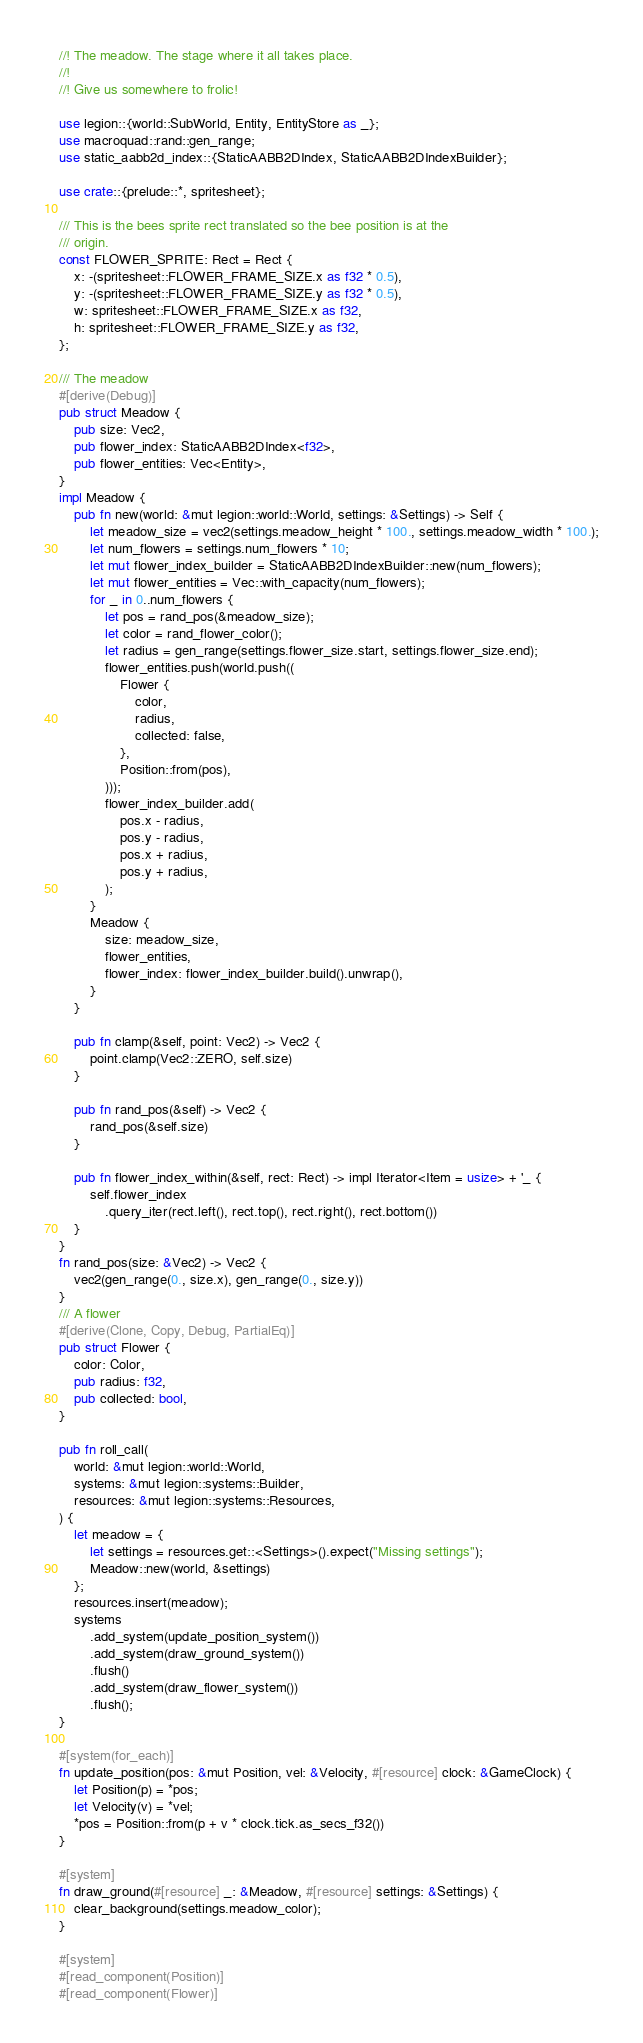<code> <loc_0><loc_0><loc_500><loc_500><_Rust_>//! The meadow. The stage where it all takes place.
//!
//! Give us somewhere to frolic!

use legion::{world::SubWorld, Entity, EntityStore as _};
use macroquad::rand::gen_range;
use static_aabb2d_index::{StaticAABB2DIndex, StaticAABB2DIndexBuilder};

use crate::{prelude::*, spritesheet};

/// This is the bees sprite rect translated so the bee position is at the
/// origin.
const FLOWER_SPRITE: Rect = Rect {
    x: -(spritesheet::FLOWER_FRAME_SIZE.x as f32 * 0.5),
    y: -(spritesheet::FLOWER_FRAME_SIZE.y as f32 * 0.5),
    w: spritesheet::FLOWER_FRAME_SIZE.x as f32,
    h: spritesheet::FLOWER_FRAME_SIZE.y as f32,
};

/// The meadow
#[derive(Debug)]
pub struct Meadow {
    pub size: Vec2,
    pub flower_index: StaticAABB2DIndex<f32>,
    pub flower_entities: Vec<Entity>,
}
impl Meadow {
    pub fn new(world: &mut legion::world::World, settings: &Settings) -> Self {
        let meadow_size = vec2(settings.meadow_height * 100., settings.meadow_width * 100.);
        let num_flowers = settings.num_flowers * 10;
        let mut flower_index_builder = StaticAABB2DIndexBuilder::new(num_flowers);
        let mut flower_entities = Vec::with_capacity(num_flowers);
        for _ in 0..num_flowers {
            let pos = rand_pos(&meadow_size);
            let color = rand_flower_color();
            let radius = gen_range(settings.flower_size.start, settings.flower_size.end);
            flower_entities.push(world.push((
                Flower {
                    color,
                    radius,
                    collected: false,
                },
                Position::from(pos),
            )));
            flower_index_builder.add(
                pos.x - radius,
                pos.y - radius,
                pos.x + radius,
                pos.y + radius,
            );
        }
        Meadow {
            size: meadow_size,
            flower_entities,
            flower_index: flower_index_builder.build().unwrap(),
        }
    }

    pub fn clamp(&self, point: Vec2) -> Vec2 {
        point.clamp(Vec2::ZERO, self.size)
    }

    pub fn rand_pos(&self) -> Vec2 {
        rand_pos(&self.size)
    }

    pub fn flower_index_within(&self, rect: Rect) -> impl Iterator<Item = usize> + '_ {
        self.flower_index
            .query_iter(rect.left(), rect.top(), rect.right(), rect.bottom())
    }
}
fn rand_pos(size: &Vec2) -> Vec2 {
    vec2(gen_range(0., size.x), gen_range(0., size.y))
}
/// A flower
#[derive(Clone, Copy, Debug, PartialEq)]
pub struct Flower {
    color: Color,
    pub radius: f32,
    pub collected: bool,
}

pub fn roll_call(
    world: &mut legion::world::World,
    systems: &mut legion::systems::Builder,
    resources: &mut legion::systems::Resources,
) {
    let meadow = {
        let settings = resources.get::<Settings>().expect("Missing settings");
        Meadow::new(world, &settings)
    };
    resources.insert(meadow);
    systems
        .add_system(update_position_system())
        .add_system(draw_ground_system())
        .flush()
        .add_system(draw_flower_system())
        .flush();
}

#[system(for_each)]
fn update_position(pos: &mut Position, vel: &Velocity, #[resource] clock: &GameClock) {
    let Position(p) = *pos;
    let Velocity(v) = *vel;
    *pos = Position::from(p + v * clock.tick.as_secs_f32())
}

#[system]
fn draw_ground(#[resource] _: &Meadow, #[resource] settings: &Settings) {
    clear_background(settings.meadow_color);
}

#[system]
#[read_component(Position)]
#[read_component(Flower)]</code> 